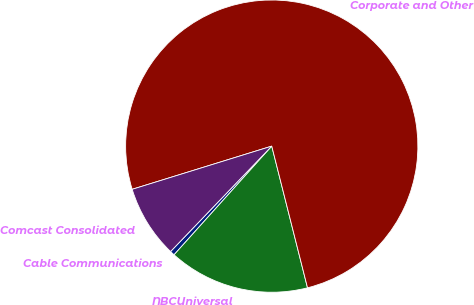Convert chart. <chart><loc_0><loc_0><loc_500><loc_500><pie_chart><fcel>Cable Communications<fcel>NBCUniversal<fcel>Corporate and Other<fcel>Comcast Consolidated<nl><fcel>0.52%<fcel>15.59%<fcel>75.84%<fcel>8.05%<nl></chart> 